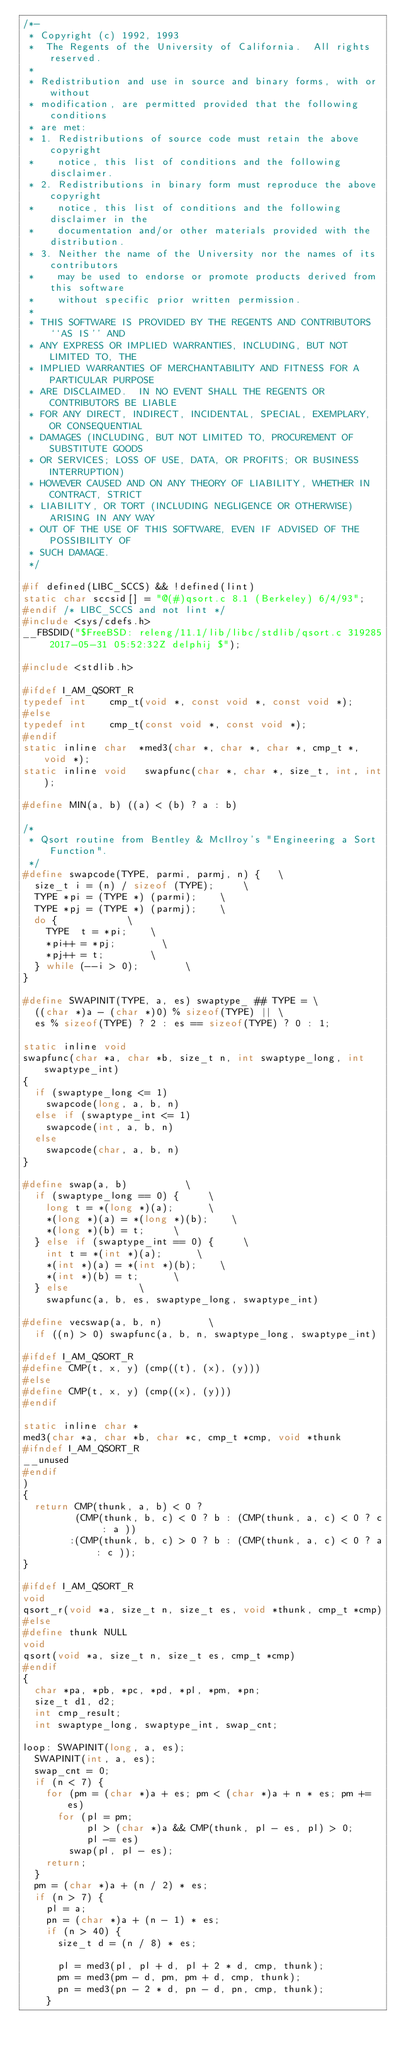Convert code to text. <code><loc_0><loc_0><loc_500><loc_500><_C_>/*-
 * Copyright (c) 1992, 1993
 *	The Regents of the University of California.  All rights reserved.
 *
 * Redistribution and use in source and binary forms, with or without
 * modification, are permitted provided that the following conditions
 * are met:
 * 1. Redistributions of source code must retain the above copyright
 *    notice, this list of conditions and the following disclaimer.
 * 2. Redistributions in binary form must reproduce the above copyright
 *    notice, this list of conditions and the following disclaimer in the
 *    documentation and/or other materials provided with the distribution.
 * 3. Neither the name of the University nor the names of its contributors
 *    may be used to endorse or promote products derived from this software
 *    without specific prior written permission.
 *
 * THIS SOFTWARE IS PROVIDED BY THE REGENTS AND CONTRIBUTORS ``AS IS'' AND
 * ANY EXPRESS OR IMPLIED WARRANTIES, INCLUDING, BUT NOT LIMITED TO, THE
 * IMPLIED WARRANTIES OF MERCHANTABILITY AND FITNESS FOR A PARTICULAR PURPOSE
 * ARE DISCLAIMED.  IN NO EVENT SHALL THE REGENTS OR CONTRIBUTORS BE LIABLE
 * FOR ANY DIRECT, INDIRECT, INCIDENTAL, SPECIAL, EXEMPLARY, OR CONSEQUENTIAL
 * DAMAGES (INCLUDING, BUT NOT LIMITED TO, PROCUREMENT OF SUBSTITUTE GOODS
 * OR SERVICES; LOSS OF USE, DATA, OR PROFITS; OR BUSINESS INTERRUPTION)
 * HOWEVER CAUSED AND ON ANY THEORY OF LIABILITY, WHETHER IN CONTRACT, STRICT
 * LIABILITY, OR TORT (INCLUDING NEGLIGENCE OR OTHERWISE) ARISING IN ANY WAY
 * OUT OF THE USE OF THIS SOFTWARE, EVEN IF ADVISED OF THE POSSIBILITY OF
 * SUCH DAMAGE.
 */

#if defined(LIBC_SCCS) && !defined(lint)
static char sccsid[] = "@(#)qsort.c	8.1 (Berkeley) 6/4/93";
#endif /* LIBC_SCCS and not lint */
#include <sys/cdefs.h>
__FBSDID("$FreeBSD: releng/11.1/lib/libc/stdlib/qsort.c 319285 2017-05-31 05:52:32Z delphij $");

#include <stdlib.h>

#ifdef I_AM_QSORT_R
typedef int		 cmp_t(void *, const void *, const void *);
#else
typedef int		 cmp_t(const void *, const void *);
#endif
static inline char	*med3(char *, char *, char *, cmp_t *, void *);
static inline void	 swapfunc(char *, char *, size_t, int, int);

#define	MIN(a, b)	((a) < (b) ? a : b)

/*
 * Qsort routine from Bentley & McIlroy's "Engineering a Sort Function".
 */
#define	swapcode(TYPE, parmi, parmj, n) {		\
	size_t i = (n) / sizeof (TYPE);			\
	TYPE *pi = (TYPE *) (parmi);		\
	TYPE *pj = (TYPE *) (parmj);		\
	do { 						\
		TYPE	t = *pi;		\
		*pi++ = *pj;				\
		*pj++ = t;				\
	} while (--i > 0);				\
}

#define	SWAPINIT(TYPE, a, es) swaptype_ ## TYPE =	\
	((char *)a - (char *)0) % sizeof(TYPE) ||	\
	es % sizeof(TYPE) ? 2 : es == sizeof(TYPE) ? 0 : 1;

static inline void
swapfunc(char *a, char *b, size_t n, int swaptype_long, int swaptype_int)
{
	if (swaptype_long <= 1)
		swapcode(long, a, b, n)
	else if (swaptype_int <= 1)
		swapcode(int, a, b, n)
	else
		swapcode(char, a, b, n)
}

#define	swap(a, b)					\
	if (swaptype_long == 0) {			\
		long t = *(long *)(a);			\
		*(long *)(a) = *(long *)(b);		\
		*(long *)(b) = t;			\
	} else if (swaptype_int == 0) {			\
		int t = *(int *)(a);			\
		*(int *)(a) = *(int *)(b);		\
		*(int *)(b) = t;			\
	} else						\
		swapfunc(a, b, es, swaptype_long, swaptype_int)

#define	vecswap(a, b, n)				\
	if ((n) > 0) swapfunc(a, b, n, swaptype_long, swaptype_int)

#ifdef I_AM_QSORT_R
#define	CMP(t, x, y) (cmp((t), (x), (y)))
#else
#define	CMP(t, x, y) (cmp((x), (y)))
#endif

static inline char *
med3(char *a, char *b, char *c, cmp_t *cmp, void *thunk
#ifndef I_AM_QSORT_R
__unused
#endif
)
{
	return CMP(thunk, a, b) < 0 ?
	       (CMP(thunk, b, c) < 0 ? b : (CMP(thunk, a, c) < 0 ? c : a ))
	      :(CMP(thunk, b, c) > 0 ? b : (CMP(thunk, a, c) < 0 ? a : c ));
}

#ifdef I_AM_QSORT_R
void
qsort_r(void *a, size_t n, size_t es, void *thunk, cmp_t *cmp)
#else
#define	thunk NULL
void
qsort(void *a, size_t n, size_t es, cmp_t *cmp)
#endif
{
	char *pa, *pb, *pc, *pd, *pl, *pm, *pn;
	size_t d1, d2;
	int cmp_result;
	int swaptype_long, swaptype_int, swap_cnt;

loop:	SWAPINIT(long, a, es);
	SWAPINIT(int, a, es);
	swap_cnt = 0;
	if (n < 7) {
		for (pm = (char *)a + es; pm < (char *)a + n * es; pm += es)
			for (pl = pm; 
			     pl > (char *)a && CMP(thunk, pl - es, pl) > 0;
			     pl -= es)
				swap(pl, pl - es);
		return;
	}
	pm = (char *)a + (n / 2) * es;
	if (n > 7) {
		pl = a;
		pn = (char *)a + (n - 1) * es;
		if (n > 40) {
			size_t d = (n / 8) * es;

			pl = med3(pl, pl + d, pl + 2 * d, cmp, thunk);
			pm = med3(pm - d, pm, pm + d, cmp, thunk);
			pn = med3(pn - 2 * d, pn - d, pn, cmp, thunk);
		}</code> 